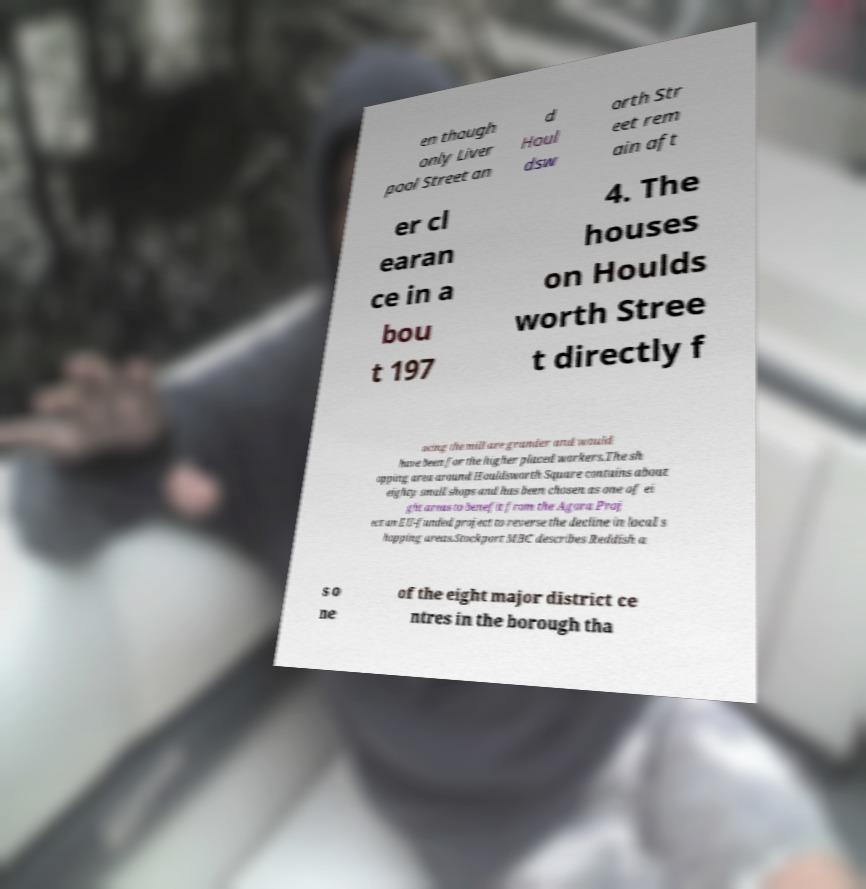Could you assist in decoding the text presented in this image and type it out clearly? en though only Liver pool Street an d Houl dsw orth Str eet rem ain aft er cl earan ce in a bou t 197 4. The houses on Houlds worth Stree t directly f acing the mill are grander and would have been for the higher placed workers.The sh opping area around Houldsworth Square contains about eighty small shops and has been chosen as one of ei ght areas to benefit from the Agora Proj ect an EU-funded project to reverse the decline in local s hopping areas.Stockport MBC describes Reddish a s o ne of the eight major district ce ntres in the borough tha 